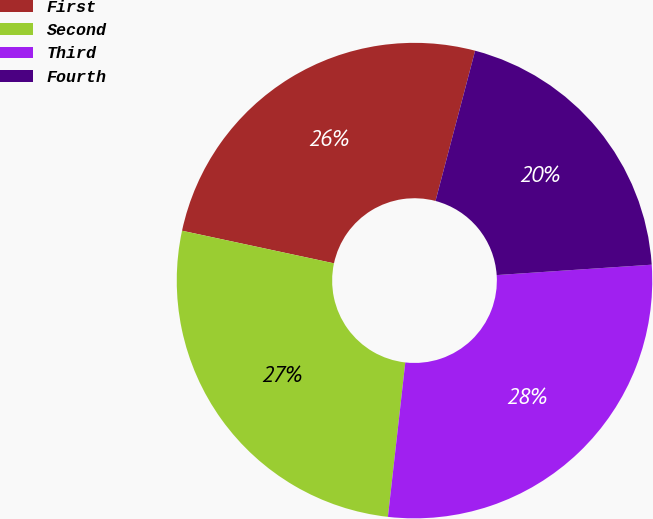<chart> <loc_0><loc_0><loc_500><loc_500><pie_chart><fcel>First<fcel>Second<fcel>Third<fcel>Fourth<nl><fcel>25.74%<fcel>26.58%<fcel>27.85%<fcel>19.83%<nl></chart> 